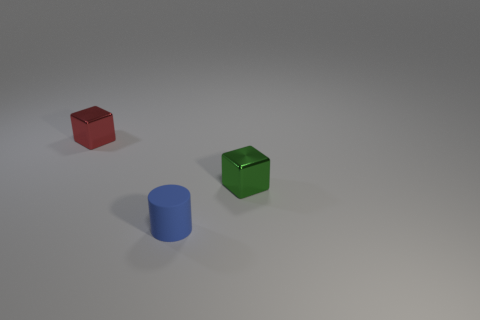Add 2 big cyan cylinders. How many objects exist? 5 Subtract 2 blocks. How many blocks are left? 0 Subtract all green cubes. How many cyan cylinders are left? 0 Subtract all tiny purple shiny blocks. Subtract all small red shiny cubes. How many objects are left? 2 Add 3 green shiny objects. How many green shiny objects are left? 4 Add 2 small green objects. How many small green objects exist? 3 Subtract all red blocks. How many blocks are left? 1 Subtract 0 brown spheres. How many objects are left? 3 Subtract all blocks. How many objects are left? 1 Subtract all yellow cubes. Subtract all cyan cylinders. How many cubes are left? 2 